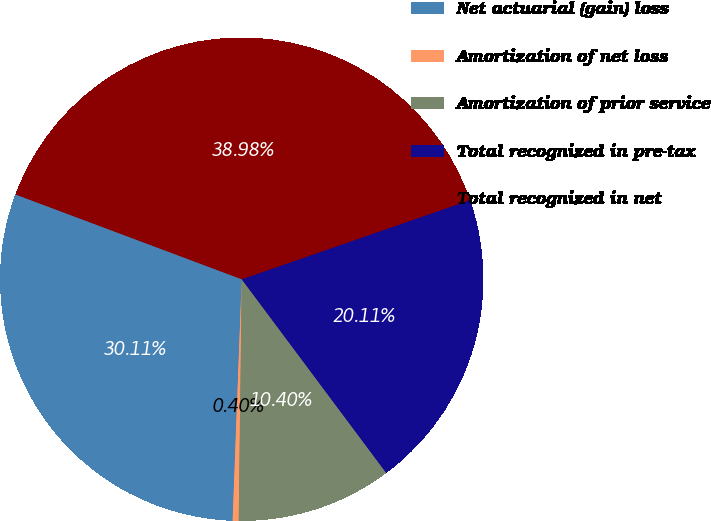Convert chart to OTSL. <chart><loc_0><loc_0><loc_500><loc_500><pie_chart><fcel>Net actuarial (gain) loss<fcel>Amortization of net loss<fcel>Amortization of prior service<fcel>Total recognized in pre-tax<fcel>Total recognized in net<nl><fcel>30.11%<fcel>0.4%<fcel>10.4%<fcel>20.11%<fcel>38.98%<nl></chart> 